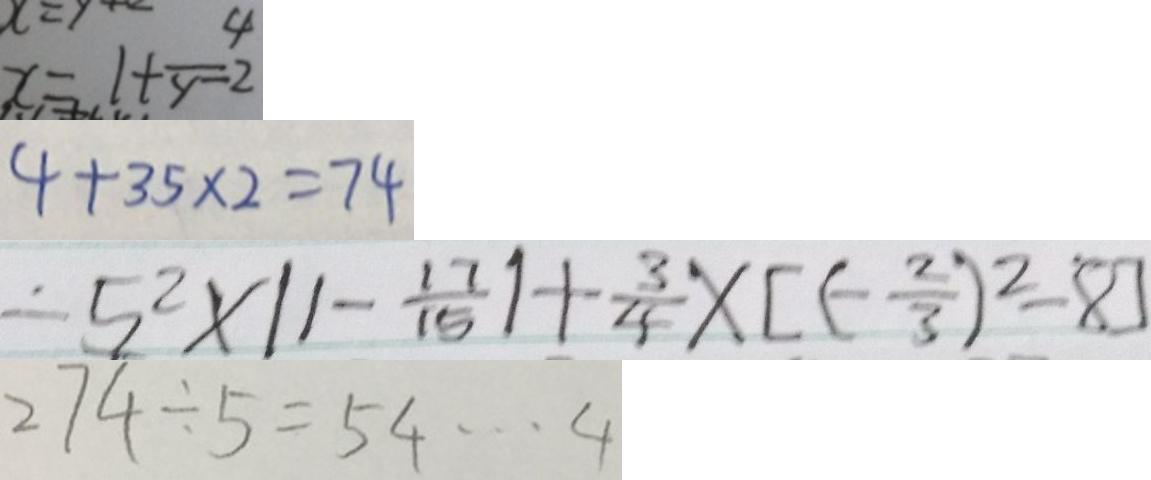<formula> <loc_0><loc_0><loc_500><loc_500>x = 1 + \frac { 4 } { y - 2 } 
 4 + 3 5 \times 2 = 7 4 
 - 5 ^ { 2 } \times \vert 1 - \frac { 1 7 } { 1 5 } \vert + \frac { 3 } { 4 } \times [ ( - \frac { 2 } { 3 } ) ^ { 2 } - 8 ] 
 2 7 4 \div 5 = 5 4 \cdots 4</formula> 